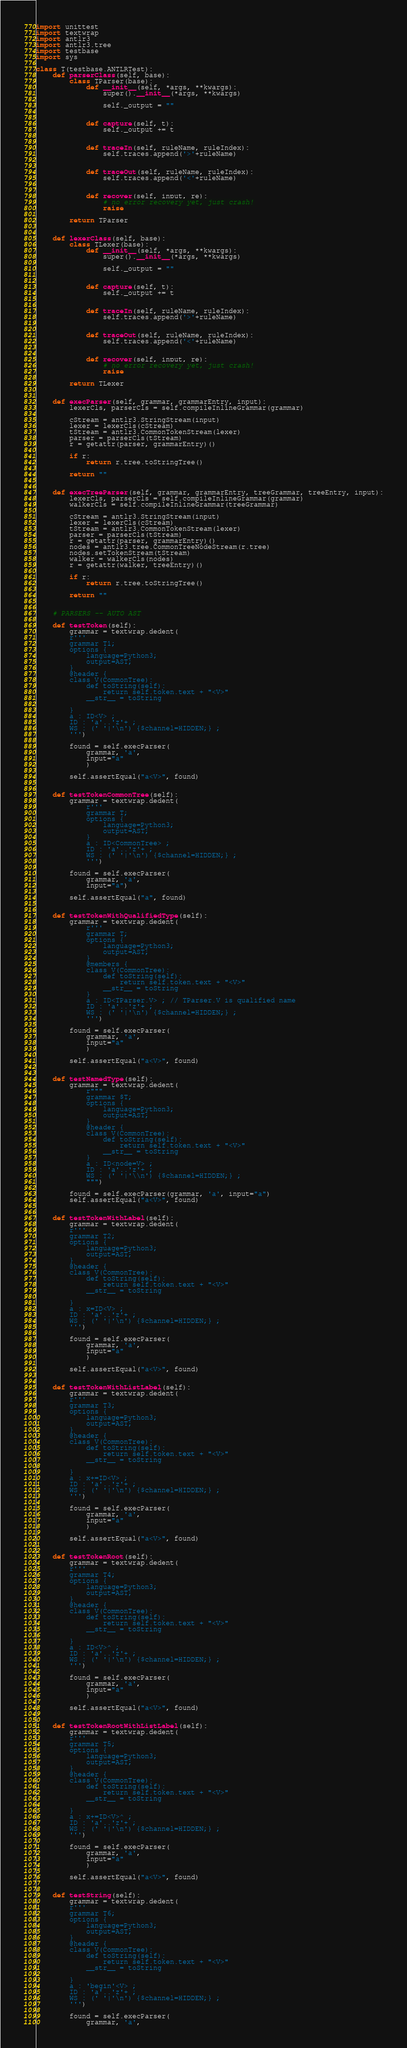<code> <loc_0><loc_0><loc_500><loc_500><_Python_>import unittest
import textwrap
import antlr3
import antlr3.tree
import testbase
import sys

class T(testbase.ANTLRTest):
    def parserClass(self, base):
        class TParser(base):
            def __init__(self, *args, **kwargs):
                super().__init__(*args, **kwargs)

                self._output = ""


            def capture(self, t):
                self._output += t


            def traceIn(self, ruleName, ruleIndex):
                self.traces.append('>'+ruleName)


            def traceOut(self, ruleName, ruleIndex):
                self.traces.append('<'+ruleName)


            def recover(self, input, re):
                # no error recovery yet, just crash!
                raise

        return TParser


    def lexerClass(self, base):
        class TLexer(base):
            def __init__(self, *args, **kwargs):
                super().__init__(*args, **kwargs)

                self._output = ""


            def capture(self, t):
                self._output += t


            def traceIn(self, ruleName, ruleIndex):
                self.traces.append('>'+ruleName)


            def traceOut(self, ruleName, ruleIndex):
                self.traces.append('<'+ruleName)


            def recover(self, input, re):
                # no error recovery yet, just crash!
                raise

        return TLexer


    def execParser(self, grammar, grammarEntry, input):
        lexerCls, parserCls = self.compileInlineGrammar(grammar)

        cStream = antlr3.StringStream(input)
        lexer = lexerCls(cStream)
        tStream = antlr3.CommonTokenStream(lexer)
        parser = parserCls(tStream)
        r = getattr(parser, grammarEntry)()

        if r:
            return r.tree.toStringTree()

        return ""


    def execTreeParser(self, grammar, grammarEntry, treeGrammar, treeEntry, input):
        lexerCls, parserCls = self.compileInlineGrammar(grammar)
        walkerCls = self.compileInlineGrammar(treeGrammar)

        cStream = antlr3.StringStream(input)
        lexer = lexerCls(cStream)
        tStream = antlr3.CommonTokenStream(lexer)
        parser = parserCls(tStream)
        r = getattr(parser, grammarEntry)()
        nodes = antlr3.tree.CommonTreeNodeStream(r.tree)
        nodes.setTokenStream(tStream)
        walker = walkerCls(nodes)
        r = getattr(walker, treeEntry)()

        if r:
            return r.tree.toStringTree()

        return ""


    # PARSERS -- AUTO AST

    def testToken(self):
        grammar = textwrap.dedent(
        r'''
        grammar T1;
        options {
            language=Python3;
            output=AST;
        }
        @header {
        class V(CommonTree):
            def toString(self):
                return self.token.text + "<V>"
            __str__ = toString

        }
        a : ID<V> ;
        ID : 'a'..'z'+ ;
        WS : (' '|'\n') {$channel=HIDDEN;} ;
        ''')

        found = self.execParser(
            grammar, 'a',
            input="a"
            )

        self.assertEqual("a<V>", found)


    def testTokenCommonTree(self):
        grammar = textwrap.dedent(
            r'''
            grammar T;
            options {
                language=Python3;
                output=AST;
            }
            a : ID<CommonTree> ;
            ID : 'a'..'z'+ ;
            WS : (' '|'\n') {$channel=HIDDEN;} ;
            ''')

        found = self.execParser(
            grammar, 'a',
            input="a")

        self.assertEqual("a", found)


    def testTokenWithQualifiedType(self):
        grammar = textwrap.dedent(
            r'''
            grammar T;
            options {
                language=Python3;
                output=AST;
            }
            @members {
            class V(CommonTree):
                def toString(self):
                    return self.token.text + "<V>"
                __str__ = toString
            }
            a : ID<TParser.V> ; // TParser.V is qualified name
            ID : 'a'..'z'+ ;
            WS : (' '|'\n') {$channel=HIDDEN;} ;
            ''')

        found = self.execParser(
            grammar, 'a',
            input="a"
            )

        self.assertEqual("a<V>", found)


    def testNamedType(self):
        grammar = textwrap.dedent(
            r"""
            grammar $T;
            options {
                language=Python3;
                output=AST;
            }
            @header {
            class V(CommonTree):
                def toString(self):
                    return self.token.text + "<V>"
                __str__ = toString
            }
            a : ID<node=V> ;
            ID : 'a'..'z'+ ;
            WS : (' '|'\\n') {$channel=HIDDEN;} ;
            """)

        found = self.execParser(grammar, 'a', input="a")
        self.assertEqual("a<V>", found)


    def testTokenWithLabel(self):
        grammar = textwrap.dedent(
        r'''
        grammar T2;
        options {
            language=Python3;
            output=AST;
        }
        @header {
        class V(CommonTree):
            def toString(self):
                return self.token.text + "<V>"
            __str__ = toString

        }
        a : x=ID<V> ;
        ID : 'a'..'z'+ ;
        WS : (' '|'\n') {$channel=HIDDEN;} ;
        ''')

        found = self.execParser(
            grammar, 'a',
            input="a"
            )

        self.assertEqual("a<V>", found)


    def testTokenWithListLabel(self):
        grammar = textwrap.dedent(
        r'''
        grammar T3;
        options {
            language=Python3;
            output=AST;
        }
        @header {
        class V(CommonTree):
            def toString(self):
                return self.token.text + "<V>"
            __str__ = toString

        }
        a : x+=ID<V> ;
        ID : 'a'..'z'+ ;
        WS : (' '|'\n') {$channel=HIDDEN;} ;
        ''')

        found = self.execParser(
            grammar, 'a',
            input="a"
            )

        self.assertEqual("a<V>", found)


    def testTokenRoot(self):
        grammar = textwrap.dedent(
        r'''
        grammar T4;
        options {
            language=Python3;
            output=AST;
        }
        @header {
        class V(CommonTree):
            def toString(self):
                return self.token.text + "<V>"
            __str__ = toString

        }
        a : ID<V>^ ;
        ID : 'a'..'z'+ ;
        WS : (' '|'\n') {$channel=HIDDEN;} ;
        ''')

        found = self.execParser(
            grammar, 'a',
            input="a"
            )

        self.assertEqual("a<V>", found)


    def testTokenRootWithListLabel(self):
        grammar = textwrap.dedent(
        r'''
        grammar T5;
        options {
            language=Python3;
            output=AST;
        }
        @header {
        class V(CommonTree):
            def toString(self):
                return self.token.text + "<V>"
            __str__ = toString

        }
        a : x+=ID<V>^ ;
        ID : 'a'..'z'+ ;
        WS : (' '|'\n') {$channel=HIDDEN;} ;
        ''')

        found = self.execParser(
            grammar, 'a',
            input="a"
            )

        self.assertEqual("a<V>", found)


    def testString(self):
        grammar = textwrap.dedent(
        r'''
        grammar T6;
        options {
            language=Python3;
            output=AST;
        }
        @header {
        class V(CommonTree):
            def toString(self):
                return self.token.text + "<V>"
            __str__ = toString

        }
        a : 'begin'<V> ;
        ID : 'a'..'z'+ ;
        WS : (' '|'\n') {$channel=HIDDEN;} ;
        ''')

        found = self.execParser(
            grammar, 'a',</code> 